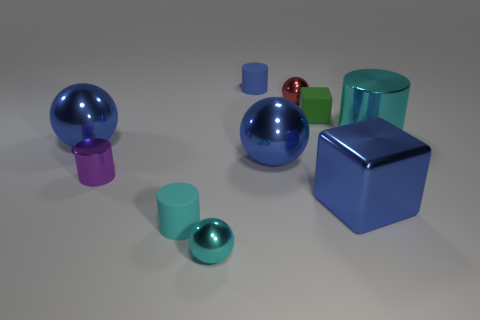What material is the cylinder that is the same color as the shiny block?
Offer a very short reply. Rubber. Is the number of tiny green matte objects that are in front of the rubber cube less than the number of large blocks that are behind the tiny cyan ball?
Make the answer very short. Yes. How many objects are tiny rubber cylinders or cyan spheres that are in front of the small purple metallic thing?
Keep it short and to the point. 3. There is a red sphere that is the same size as the green matte object; what is its material?
Provide a short and direct response. Metal. Is the material of the cyan sphere the same as the big blue cube?
Offer a very short reply. Yes. There is a shiny thing that is both on the right side of the green rubber block and in front of the large metallic cylinder; what is its color?
Keep it short and to the point. Blue. Do the thing behind the red thing and the tiny shiny cylinder have the same color?
Provide a short and direct response. No. There is a green matte thing that is the same size as the blue rubber cylinder; what shape is it?
Offer a terse response. Cube. How many other things are there of the same color as the large cylinder?
Your answer should be compact. 2. How many other things are made of the same material as the blue cylinder?
Your answer should be very brief. 2. 